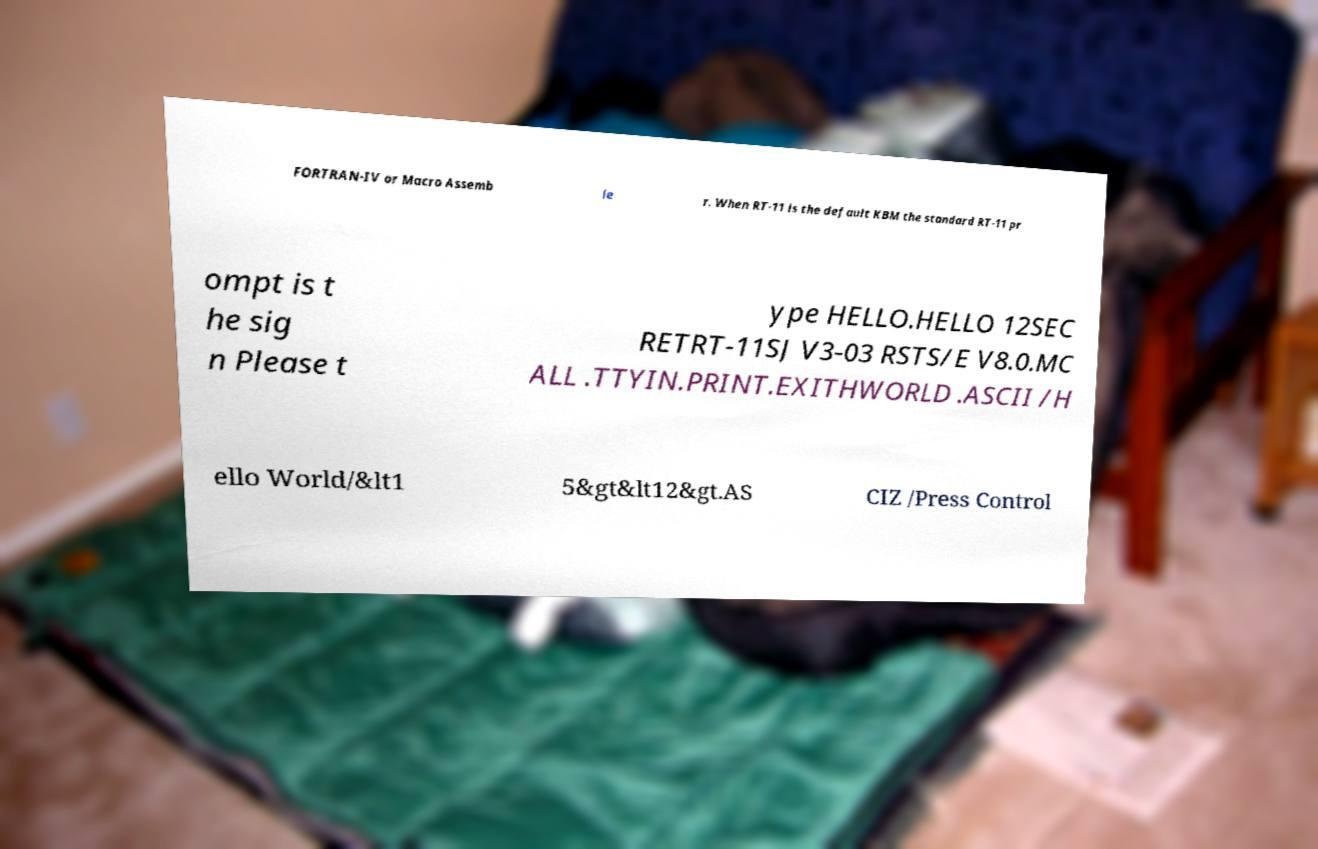Could you assist in decoding the text presented in this image and type it out clearly? FORTRAN-IV or Macro Assemb le r. When RT-11 is the default KBM the standard RT-11 pr ompt is t he sig n Please t ype HELLO.HELLO 12SEC RETRT-11SJ V3-03 RSTS/E V8.0.MC ALL .TTYIN.PRINT.EXITHWORLD .ASCII /H ello World/&lt1 5&gt&lt12&gt.AS CIZ /Press Control 